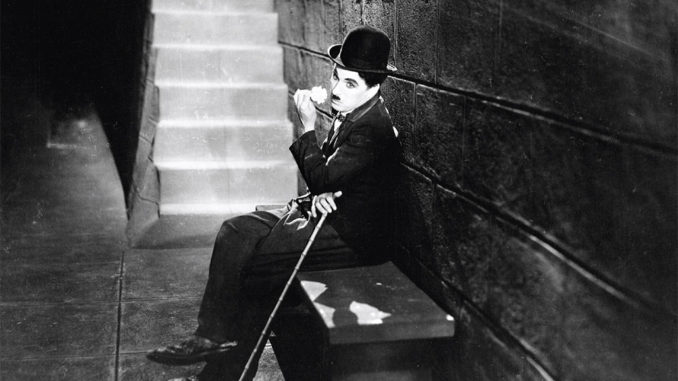Analyze the image in a comprehensive and detailed manner. This black and white photograph captures Charles Chaplin as his renowned character, the Tramp, a symbol of the silent film era that blended comedy and pathos. Chaplin is depicted sitting alone on a stone bench, which adds a sense of isolation to the scene. His legs are elegantly crossed, and he holds his signature cane, reinforcing his on-screen persona. The bowler hat and suit, along with his distinctive small mustache, are quintessential elements of his costume. The setting features a dimly lit staircase and a rough stone wall, which might suggest an urban environment typical of many settings in his films, evoking themes of industrialization and its social impacts during the early 20th century. His contemplative gaze and the overall lighting contribute to a poignant atmosphere, inviting viewers to ponder the social commentary often present in his work. 